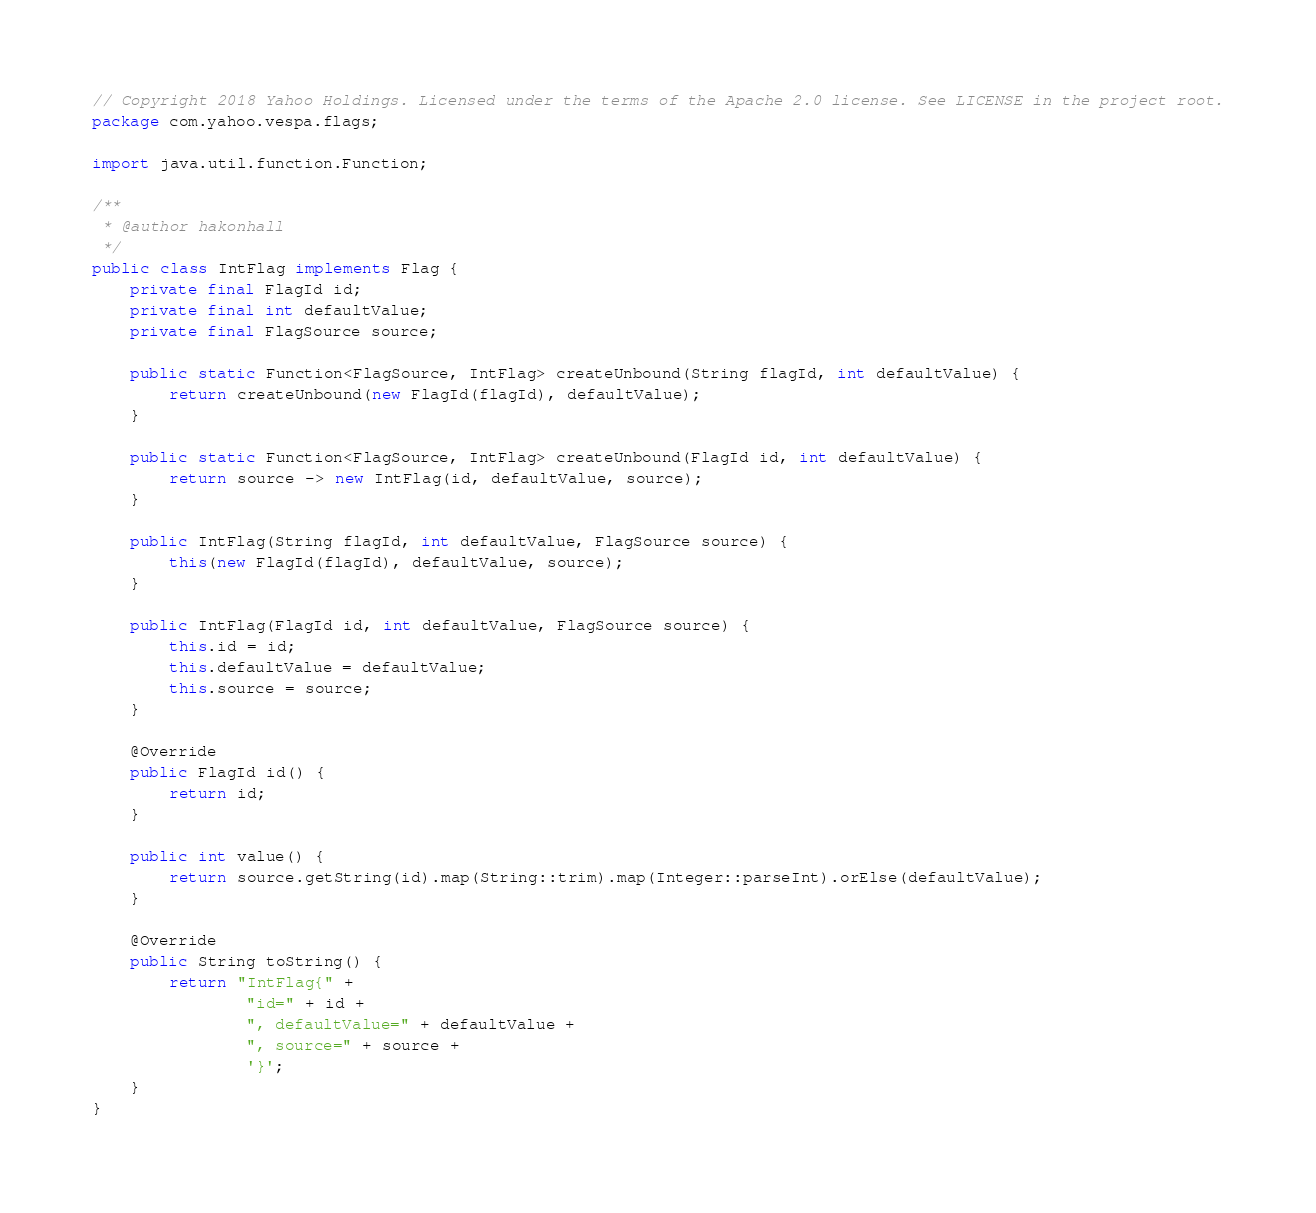Convert code to text. <code><loc_0><loc_0><loc_500><loc_500><_Java_>// Copyright 2018 Yahoo Holdings. Licensed under the terms of the Apache 2.0 license. See LICENSE in the project root.
package com.yahoo.vespa.flags;

import java.util.function.Function;

/**
 * @author hakonhall
 */
public class IntFlag implements Flag {
    private final FlagId id;
    private final int defaultValue;
    private final FlagSource source;

    public static Function<FlagSource, IntFlag> createUnbound(String flagId, int defaultValue) {
        return createUnbound(new FlagId(flagId), defaultValue);
    }

    public static Function<FlagSource, IntFlag> createUnbound(FlagId id, int defaultValue) {
        return source -> new IntFlag(id, defaultValue, source);
    }

    public IntFlag(String flagId, int defaultValue, FlagSource source) {
        this(new FlagId(flagId), defaultValue, source);
    }

    public IntFlag(FlagId id, int defaultValue, FlagSource source) {
        this.id = id;
        this.defaultValue = defaultValue;
        this.source = source;
    }

    @Override
    public FlagId id() {
        return id;
    }

    public int value() {
        return source.getString(id).map(String::trim).map(Integer::parseInt).orElse(defaultValue);
    }

    @Override
    public String toString() {
        return "IntFlag{" +
                "id=" + id +
                ", defaultValue=" + defaultValue +
                ", source=" + source +
                '}';
    }
}
</code> 